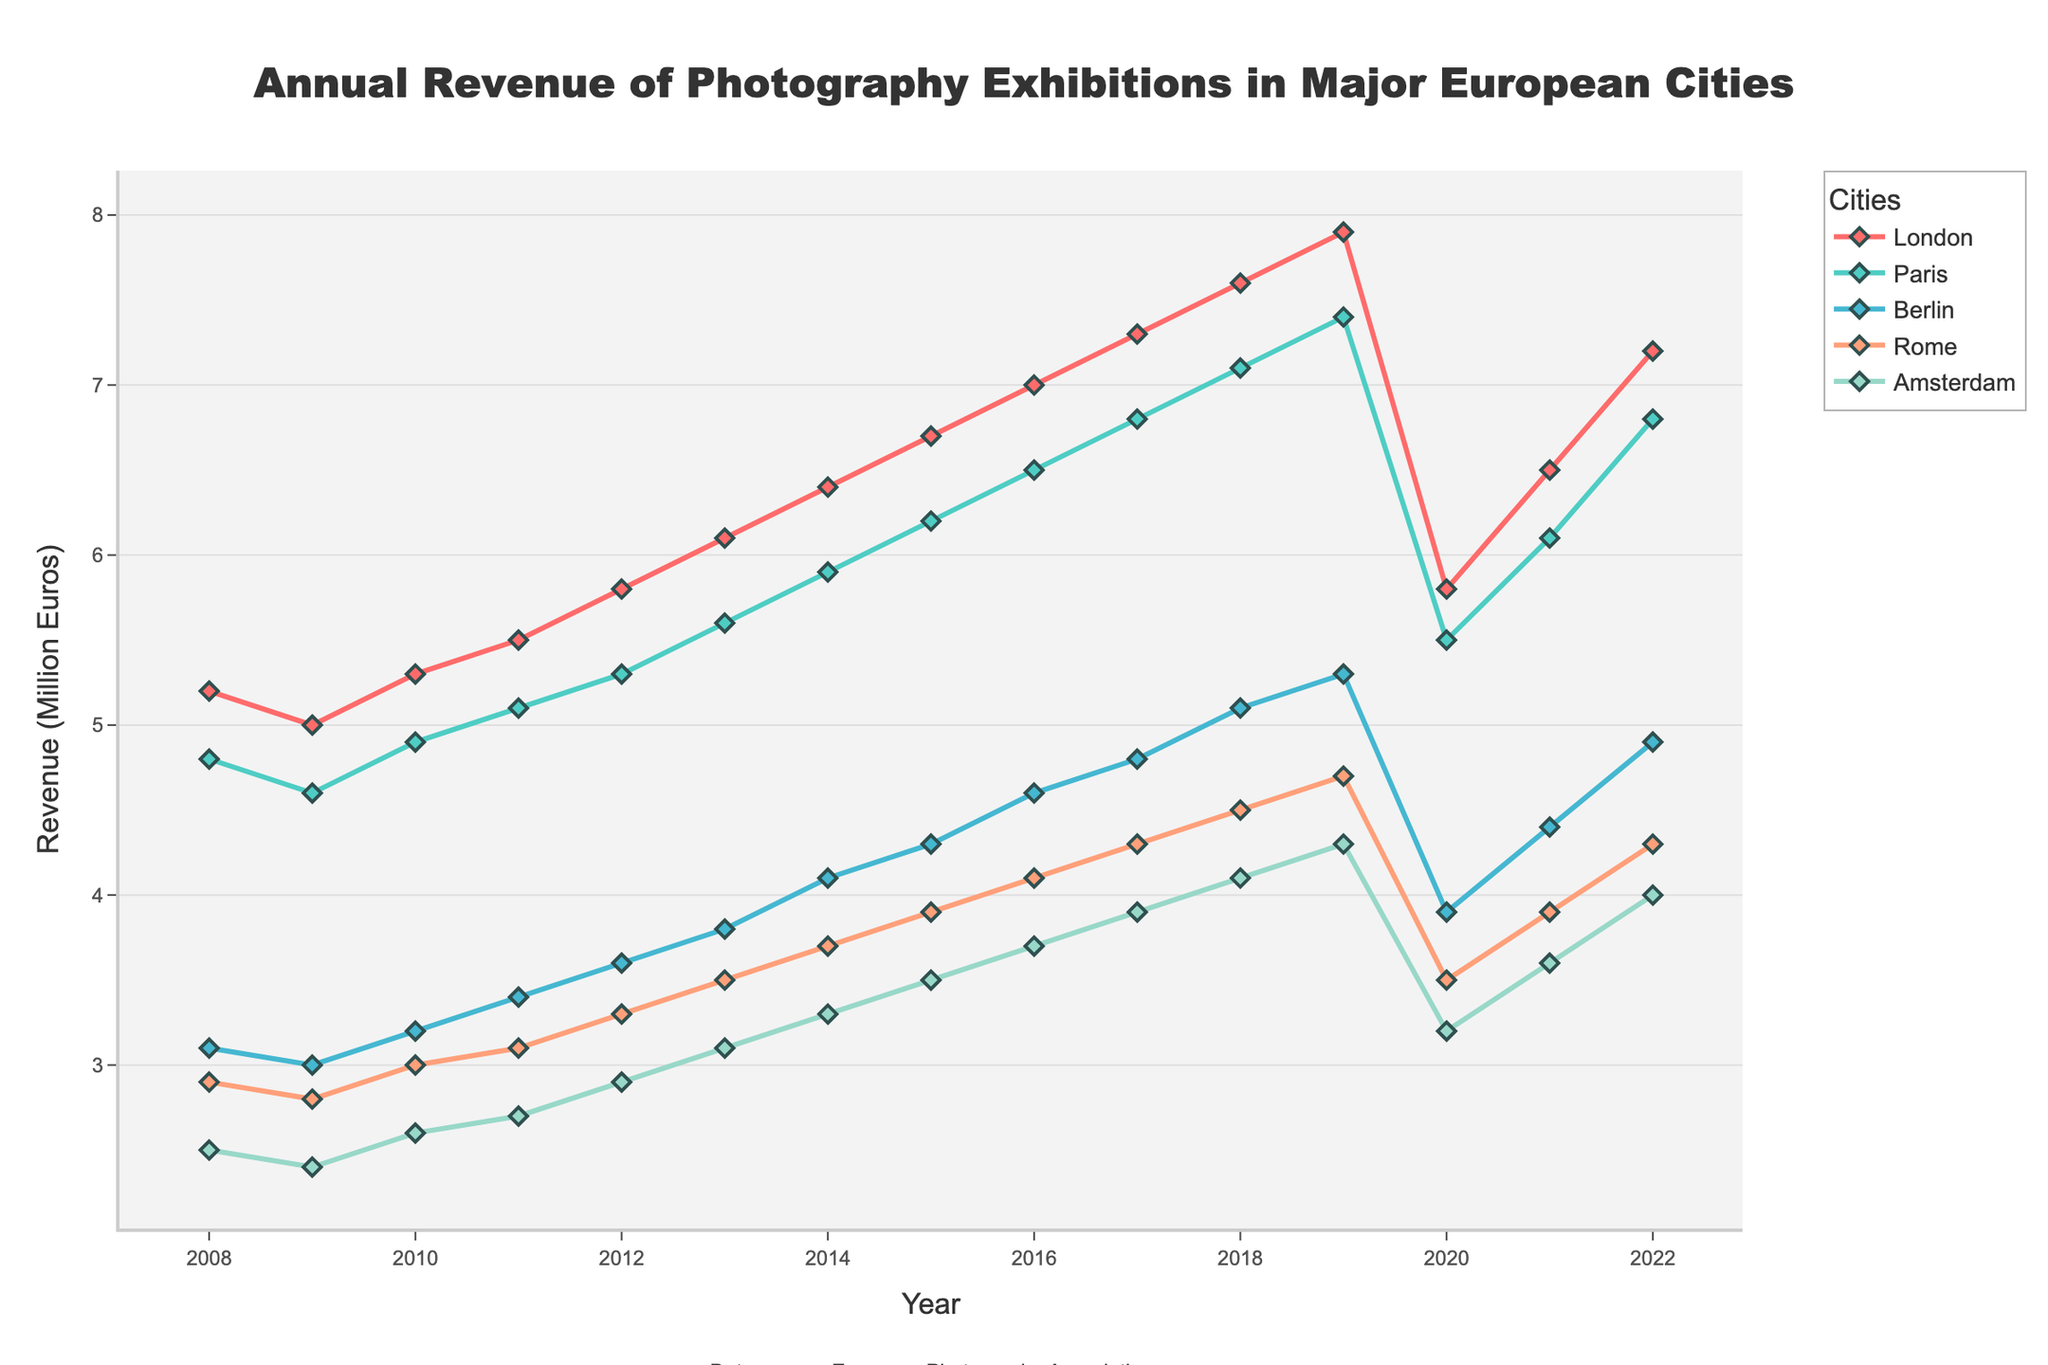Which city had the highest revenue in 2019? To find the highest revenue in 2019, check the values of all cities for that year. London has the highest revenue of 7.9 million Euros.
Answer: London Which city showed the largest drop in revenue between 2019 and 2020? Compare the revenue for each city between 2019 and 2020. London dropped from 7.9 million to 5.8 million Euros, which is the largest drop of 2.1 million Euros.
Answer: London What was the average revenue for Berlin over the 15 years? Calculate the sum of all revenues for Berlin from 2008 to 2022 and divide by the number of years (15). The sum is 61.3 million Euros, so the average is 61.3 / 15 = 4.1 million Euros.
Answer: 4.1 million Euros Which city had the smallest revenue in 2008, and what was the amount? Check the revenue values for all cities in 2008. Amsterdam had the smallest revenue with 2.5 million Euros.
Answer: Amsterdam, 2.5 million Euros What is the total revenue of Paris from 2017 to 2019? Add the revenue values of Paris for the years 2017 (6.8 million), 2018 (7.1 million), and 2019 (7.4 million). The total is 6.8 + 7.1 + 7.4 = 21.3 million Euros.
Answer: 21.3 million Euros Which city had a consistent growth in revenue from 2008 to 2019? Analyze the revenue lines for each city over the period from 2008 to 2019. London consistently increased its revenue every year from 5.2 million to 7.9 million Euros.
Answer: London What is the median revenue of Rome over the 15 years? List all revenues of Rome from 2008 to 2022 and find the middle value. The sorted list is [2.8, 2.9, 3.0, 3.1, 3.3, 3.5, 3.5, 3.7, 3.9, 3.9, 4.1, 4.3, 4.3, 4.5, 4.7]. The median value is 3.7 million Euros.
Answer: 3.7 million Euros Which two cities have the closest revenue in 2022? Compare the revenue values of all cities in 2022. Berlin and Rome have the closest revenues of 4.9 million and 4.3 million Euros, respectively, with a difference of 0.6 million Euros.
Answer: Berlin and Rome How much did Amsterdam’s revenue increase from 2008 to 2019? Find the difference between Amsterdam’s revenue in 2019 (4.3 million Euros) and 2008 (2.5 million Euros). The increase is 4.3 - 2.5 = 1.8 million Euros.
Answer: 1.8 million Euros Which city had the lowest average revenue over the 15 years? Calculate the average revenue for each city from 2008 to 2022 and find the smallest value. Amsterdam's total revenue is 47.1 million Euros, hence its average is 47.1 / 15 = 3.1 million Euros, which is the lowest.
Answer: Amsterdam 